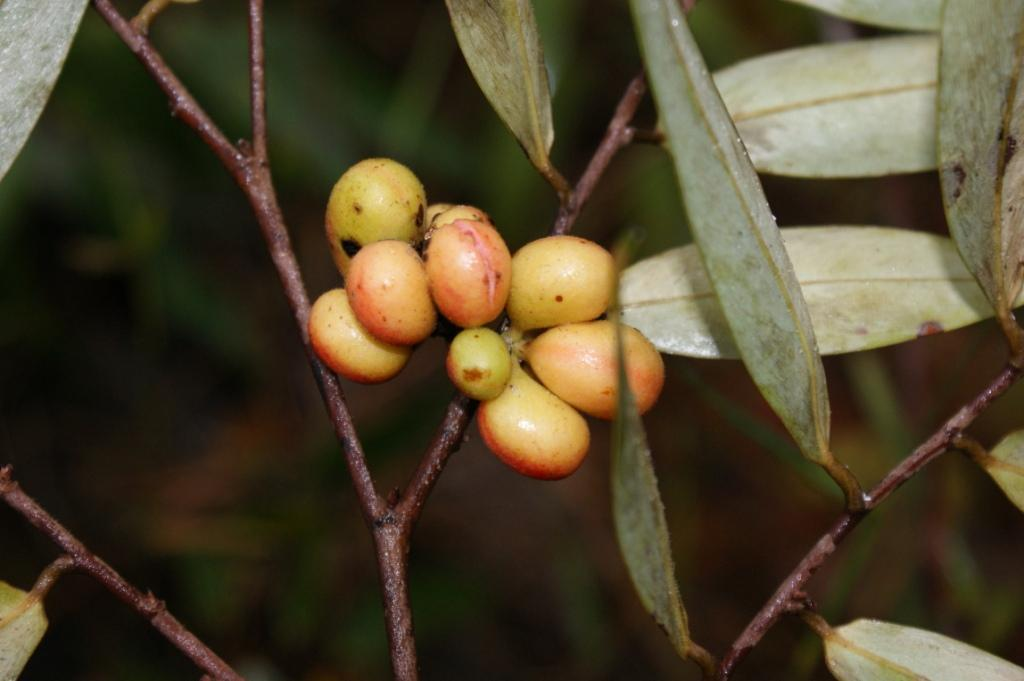What type of vegetation is present in the image? There are green leaves in the image. What can be found on the trees with green leaves? There are fruits on the trees with green leaves. What is the chance of winning a prize at the cemetery in the image? There is no cemetery present in the image, and therefore no chance of winning a prize can be determined. 